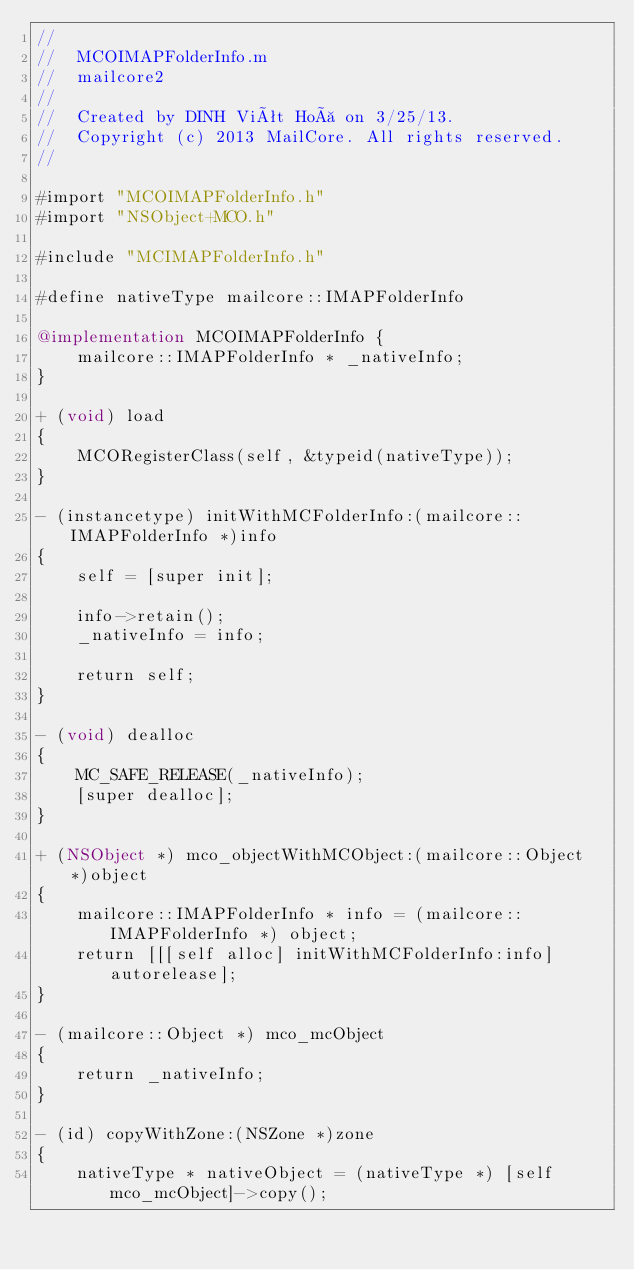Convert code to text. <code><loc_0><loc_0><loc_500><loc_500><_ObjectiveC_>//
//  MCOIMAPFolderInfo.m
//  mailcore2
//
//  Created by DINH Viêt Hoà on 3/25/13.
//  Copyright (c) 2013 MailCore. All rights reserved.
//

#import "MCOIMAPFolderInfo.h"
#import "NSObject+MCO.h"

#include "MCIMAPFolderInfo.h"

#define nativeType mailcore::IMAPFolderInfo

@implementation MCOIMAPFolderInfo {
    mailcore::IMAPFolderInfo * _nativeInfo;
}

+ (void) load
{
    MCORegisterClass(self, &typeid(nativeType));
}

- (instancetype) initWithMCFolderInfo:(mailcore::IMAPFolderInfo *)info
{
    self = [super init];

    info->retain();
    _nativeInfo = info;

    return self;
}

- (void) dealloc
{
    MC_SAFE_RELEASE(_nativeInfo);
    [super dealloc];
}

+ (NSObject *) mco_objectWithMCObject:(mailcore::Object *)object
{
    mailcore::IMAPFolderInfo * info = (mailcore::IMAPFolderInfo *) object;
    return [[[self alloc] initWithMCFolderInfo:info] autorelease];
}

- (mailcore::Object *) mco_mcObject
{
    return _nativeInfo;
}

- (id) copyWithZone:(NSZone *)zone
{
    nativeType * nativeObject = (nativeType *) [self mco_mcObject]->copy();</code> 